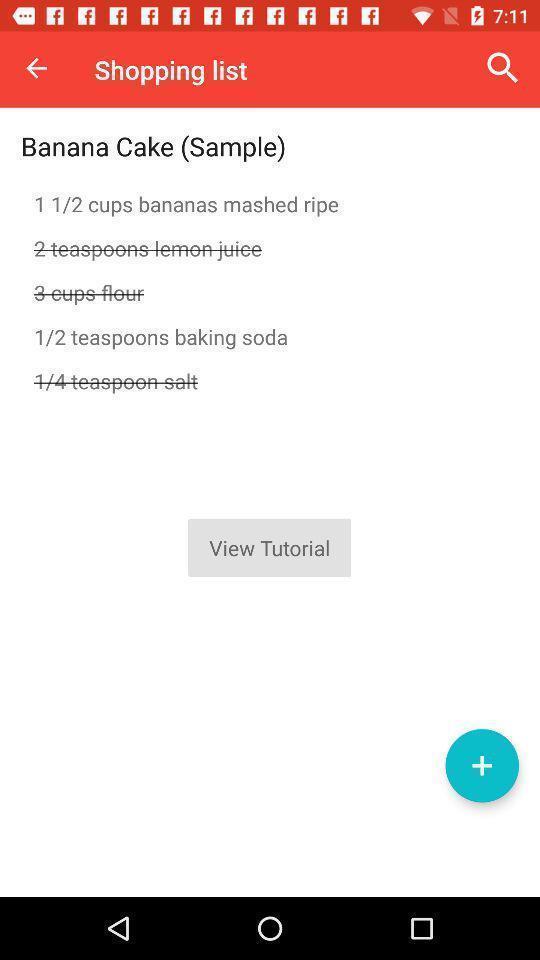Please provide a description for this image. Recipe page in a cooking app. 